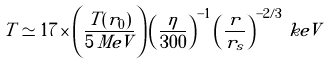Convert formula to latex. <formula><loc_0><loc_0><loc_500><loc_500>T \simeq 1 7 \times \left ( \frac { T ( r _ { 0 } ) } { 5 \, M e V } \right ) \left ( \frac { \eta } { 3 0 0 } \right ) ^ { - 1 } \left ( \frac { r } { r _ { s } } \right ) ^ { - 2 / 3 } \, k e V</formula> 